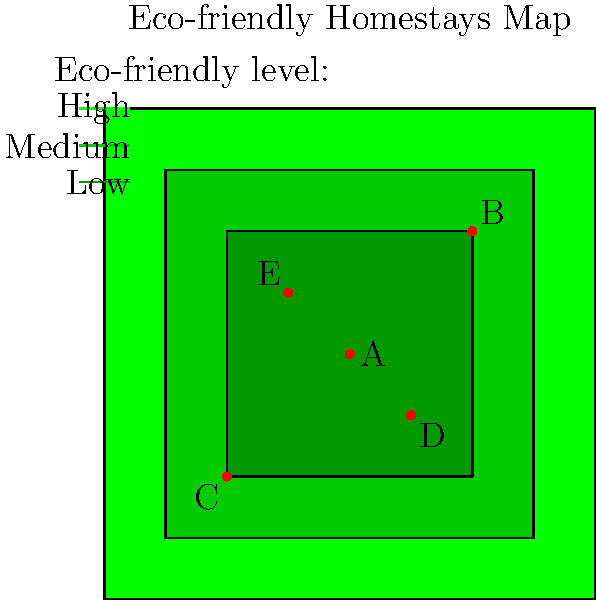Based on the map of eco-friendly homestays, which homestay is located in the region with the highest eco-friendly rating and is closest to the center of the map? To answer this question, we need to follow these steps:

1. Identify the regions with different eco-friendly ratings:
   - The outermost region (lightest green) represents the lowest eco-friendly rating.
   - The middle region (medium green) represents a medium eco-friendly rating.
   - The innermost region (darkest green) represents the highest eco-friendly rating.

2. Locate the homestays on the map:
   - Homestay A is at the center (0,0)
   - Homestay B is at the top-right corner (1,1)
   - Homestay C is at the bottom-left corner (-1,-1)
   - Homestay D is at (0.5,-0.5)
   - Homestay E is at (-0.5,0.5)

3. Determine which homestays are in the highest eco-friendly region:
   - Homestays A, D, and E are within the innermost (darkest green) region.

4. Among these homestays, identify which one is closest to the center:
   - Homestay A is exactly at the center (0,0).
   - Homestays D and E are further from the center.

Therefore, Homestay A is both in the highest eco-friendly region and closest to the center of the map.
Answer: Homestay A 